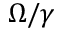<formula> <loc_0><loc_0><loc_500><loc_500>\Omega / \gamma</formula> 